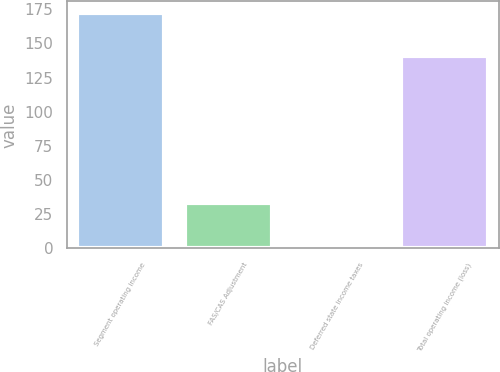Convert chart. <chart><loc_0><loc_0><loc_500><loc_500><bar_chart><fcel>Segment operating income<fcel>FAS/CAS Adjustment<fcel>Deferred state income taxes<fcel>Total operating income (loss)<nl><fcel>172<fcel>33<fcel>2<fcel>141<nl></chart> 